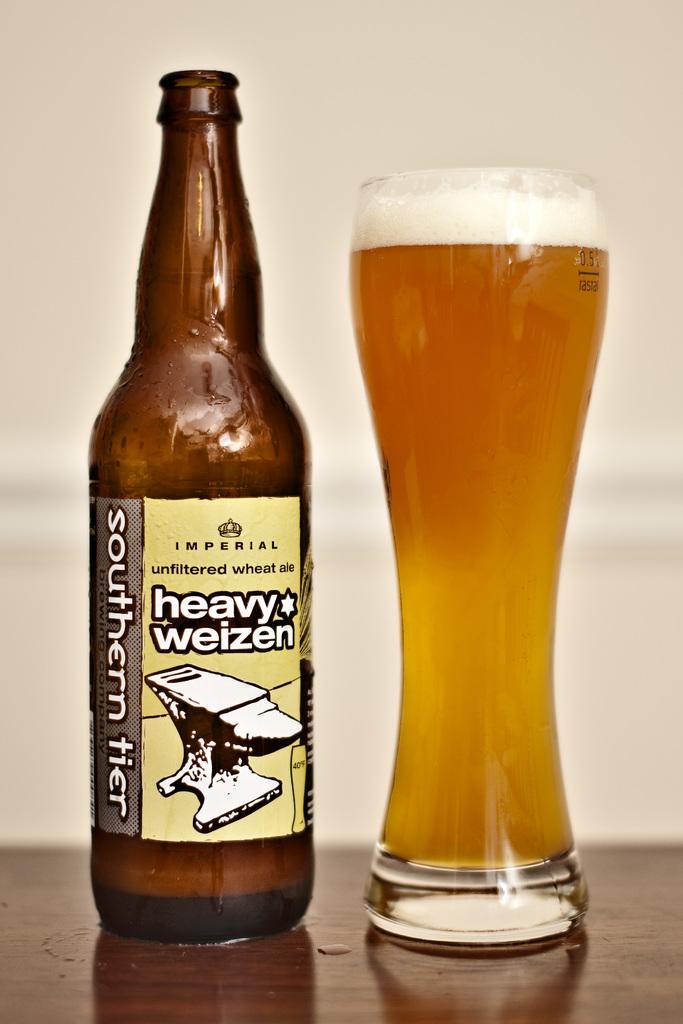What brand is the beer in the bottle?
Provide a succinct answer. Heavy weizen. 